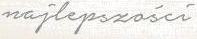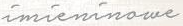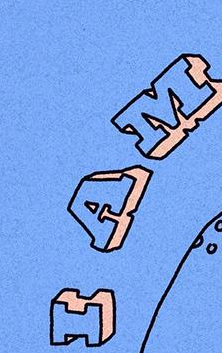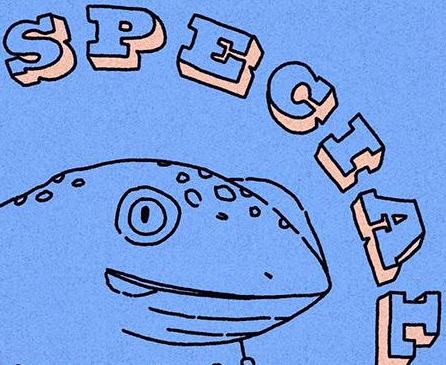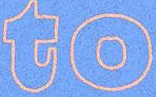Identify the words shown in these images in order, separated by a semicolon. najlepszości; imieninowe; IAM; SPECIAL; to 